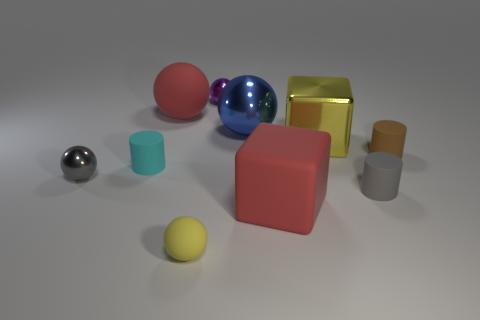Does the large matte ball have the same color as the rubber cube?
Ensure brevity in your answer.  Yes. Is the large blue object made of the same material as the large red block?
Offer a very short reply. No. What number of small things are cyan matte objects or red rubber objects?
Offer a very short reply. 1. What is the color of the cube that is made of the same material as the tiny purple ball?
Your answer should be very brief. Yellow. There is a shiny object left of the small purple shiny ball; what color is it?
Keep it short and to the point. Gray. What number of other cubes are the same color as the metal cube?
Your response must be concise. 0. Are there fewer big metal blocks that are on the left side of the blue sphere than objects to the right of the tiny cyan rubber object?
Keep it short and to the point. Yes. What number of yellow balls are right of the small gray metallic ball?
Your answer should be very brief. 1. Are there any tiny things that have the same material as the gray ball?
Your answer should be very brief. Yes. Are there more metallic spheres that are in front of the small purple metallic thing than red matte cubes left of the large red rubber sphere?
Provide a short and direct response. Yes. 